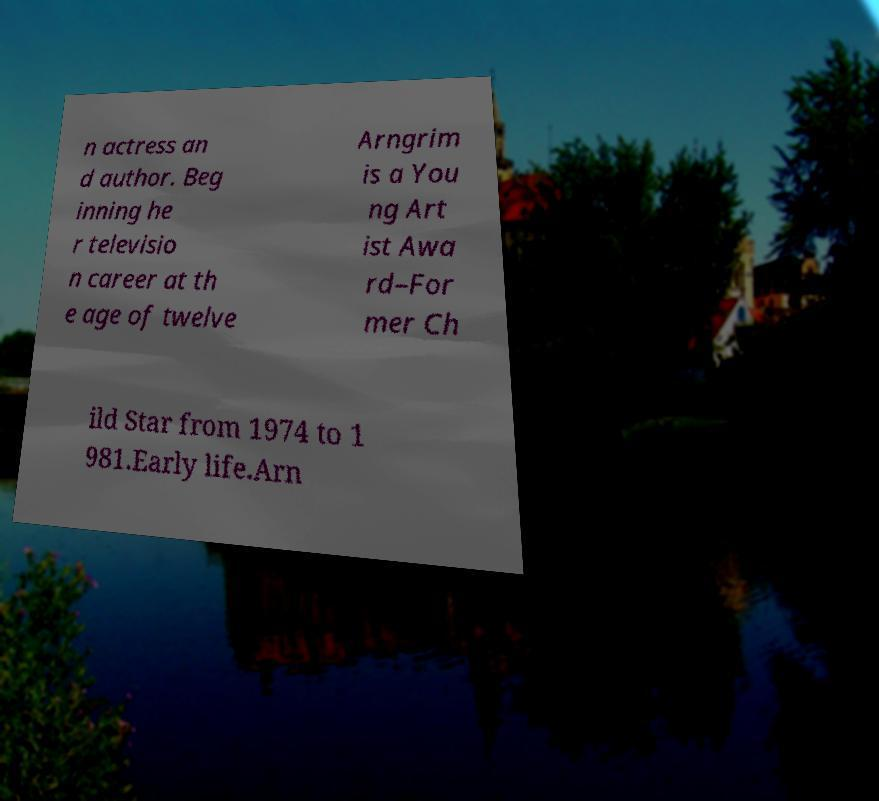Please identify and transcribe the text found in this image. n actress an d author. Beg inning he r televisio n career at th e age of twelve Arngrim is a You ng Art ist Awa rd–For mer Ch ild Star from 1974 to 1 981.Early life.Arn 